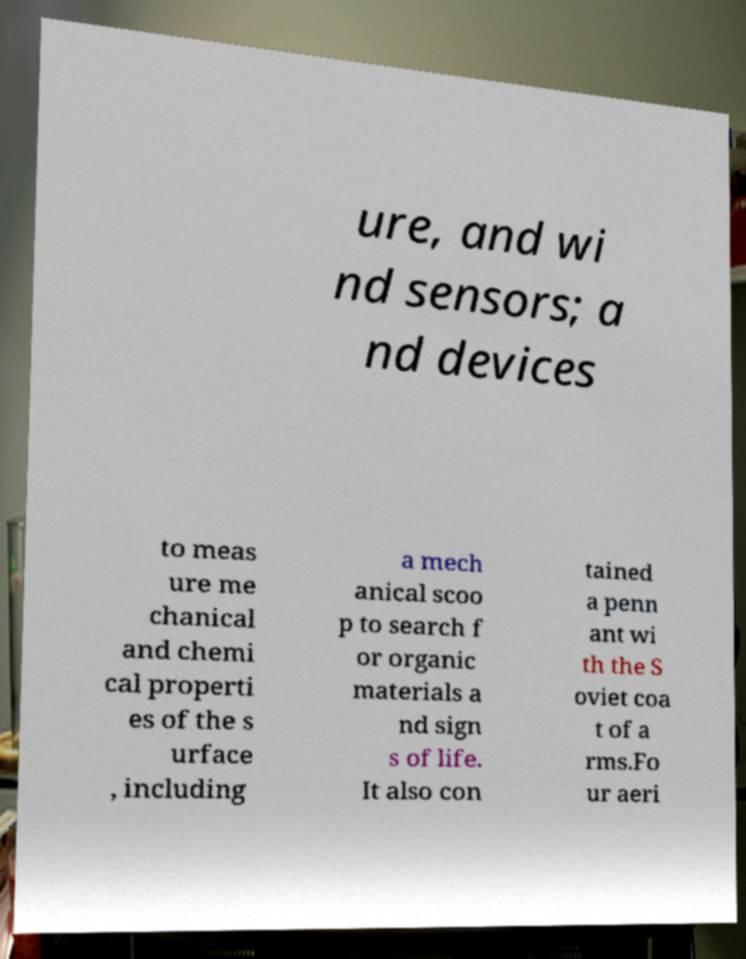Could you assist in decoding the text presented in this image and type it out clearly? ure, and wi nd sensors; a nd devices to meas ure me chanical and chemi cal properti es of the s urface , including a mech anical scoo p to search f or organic materials a nd sign s of life. It also con tained a penn ant wi th the S oviet coa t of a rms.Fo ur aeri 